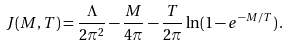Convert formula to latex. <formula><loc_0><loc_0><loc_500><loc_500>J ( M , T ) = \frac { \Lambda } { 2 \pi ^ { 2 } } - \frac { M } { 4 \pi } - \frac { T } { 2 \pi } \ln ( 1 - e ^ { - M / T } ) \, .</formula> 